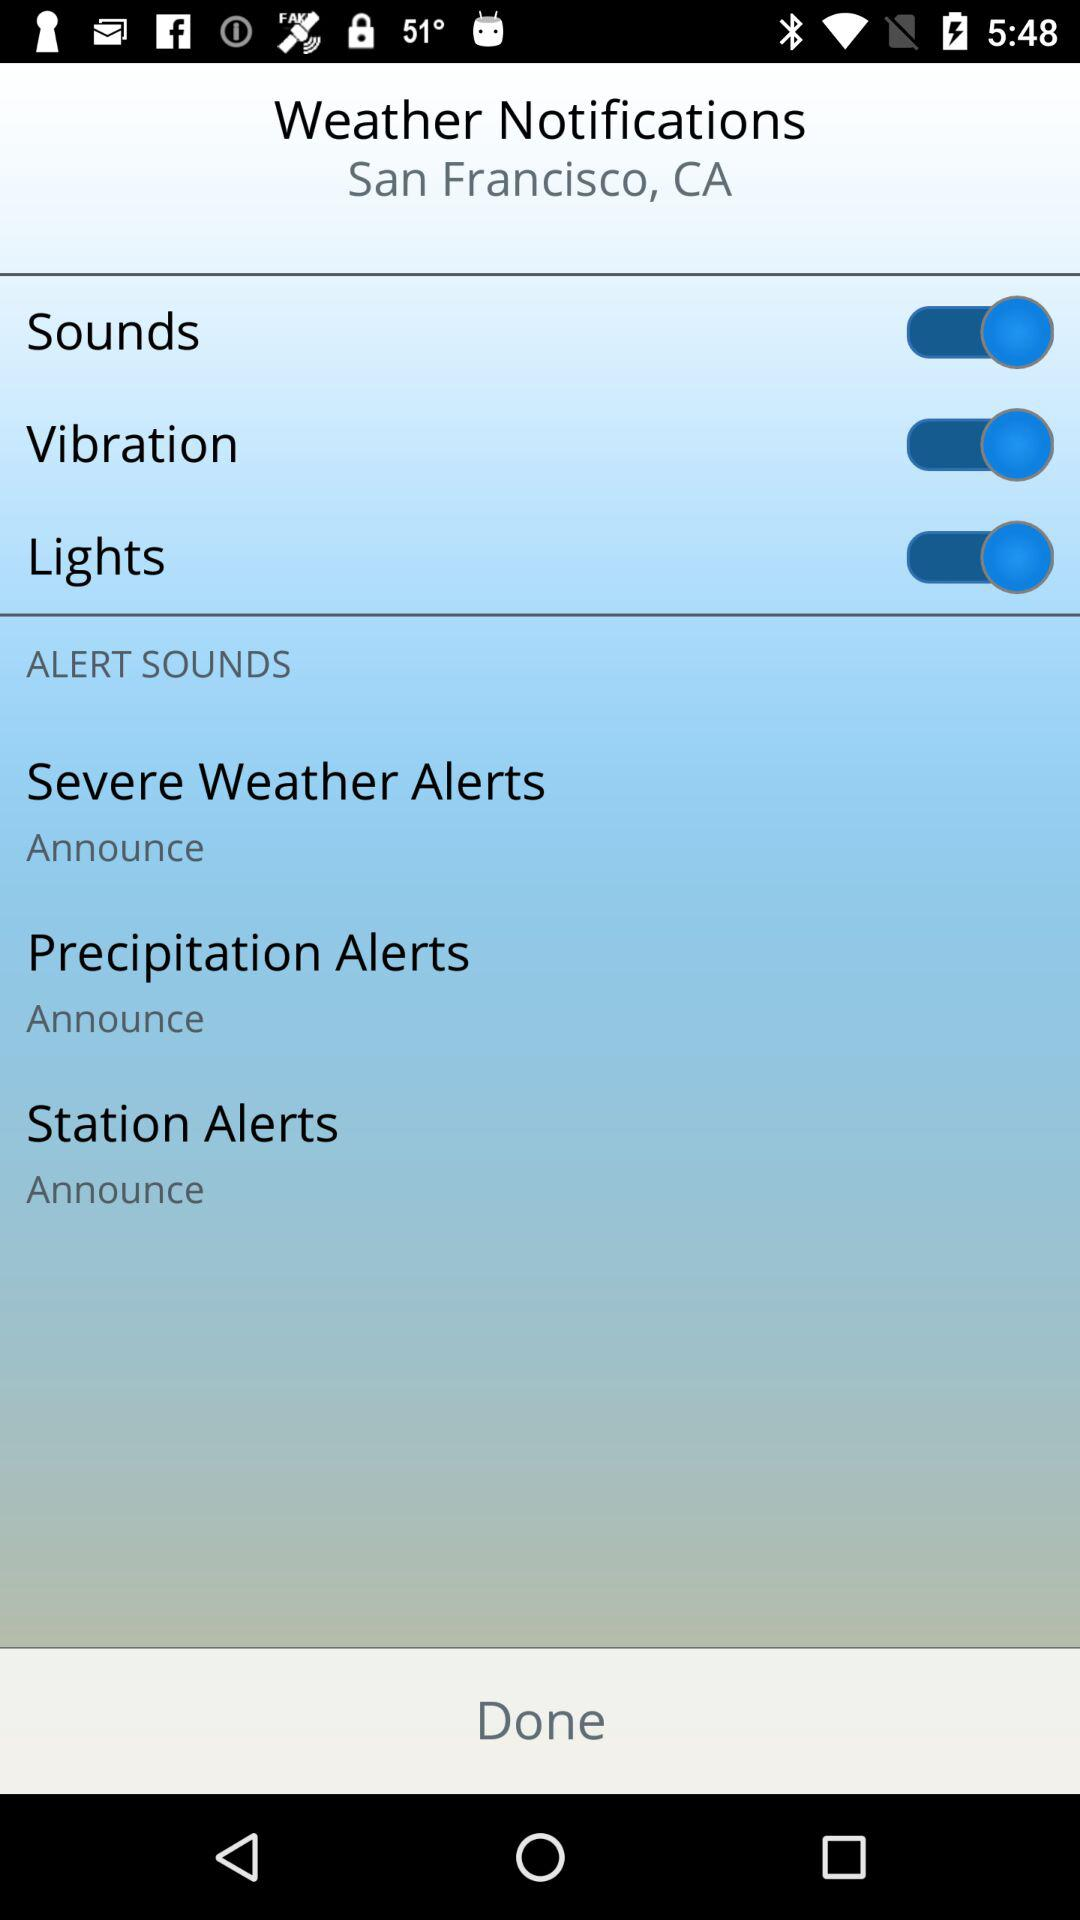How many alert types are there?
Answer the question using a single word or phrase. 3 